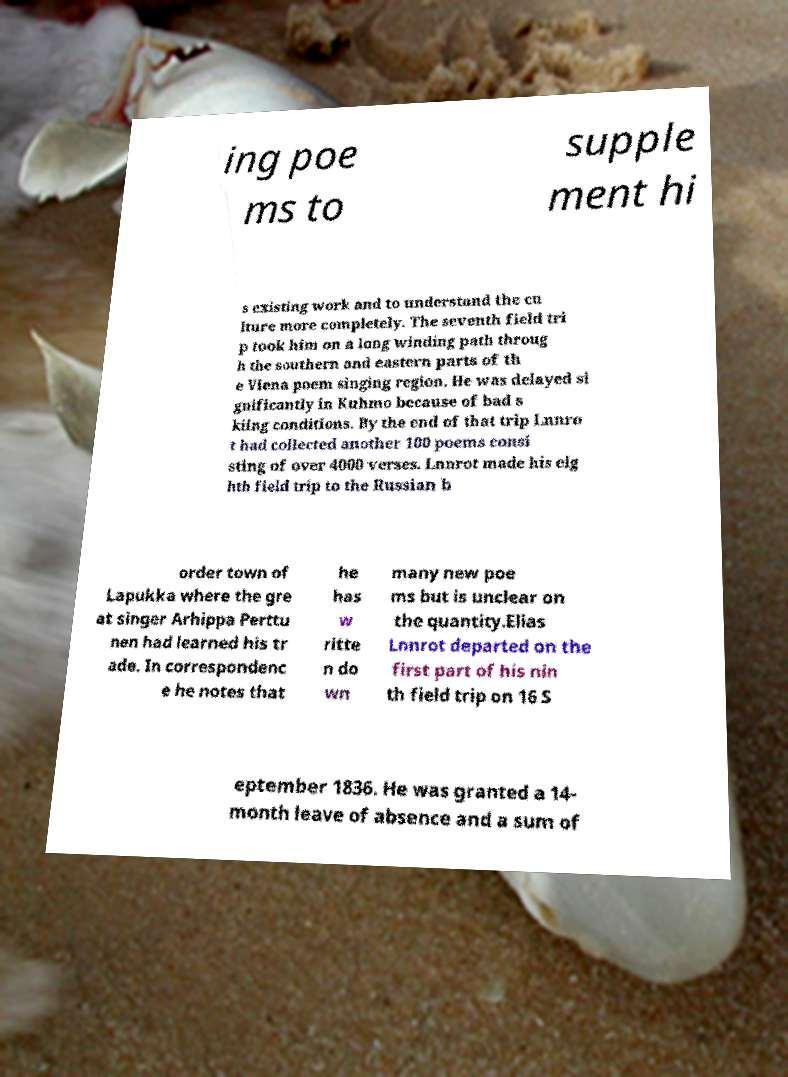What messages or text are displayed in this image? I need them in a readable, typed format. ing poe ms to supple ment hi s existing work and to understand the cu lture more completely. The seventh field tri p took him on a long winding path throug h the southern and eastern parts of th e Viena poem singing region. He was delayed si gnificantly in Kuhmo because of bad s kiing conditions. By the end of that trip Lnnro t had collected another 100 poems consi sting of over 4000 verses. Lnnrot made his eig hth field trip to the Russian b order town of Lapukka where the gre at singer Arhippa Perttu nen had learned his tr ade. In correspondenc e he notes that he has w ritte n do wn many new poe ms but is unclear on the quantity.Elias Lnnrot departed on the first part of his nin th field trip on 16 S eptember 1836. He was granted a 14- month leave of absence and a sum of 